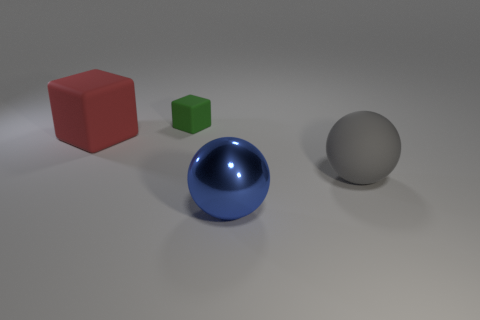Add 1 big matte objects. How many objects exist? 5 Subtract all rubber balls. Subtract all large shiny objects. How many objects are left? 2 Add 1 spheres. How many spheres are left? 3 Add 4 small green blocks. How many small green blocks exist? 5 Subtract 0 blue cylinders. How many objects are left? 4 